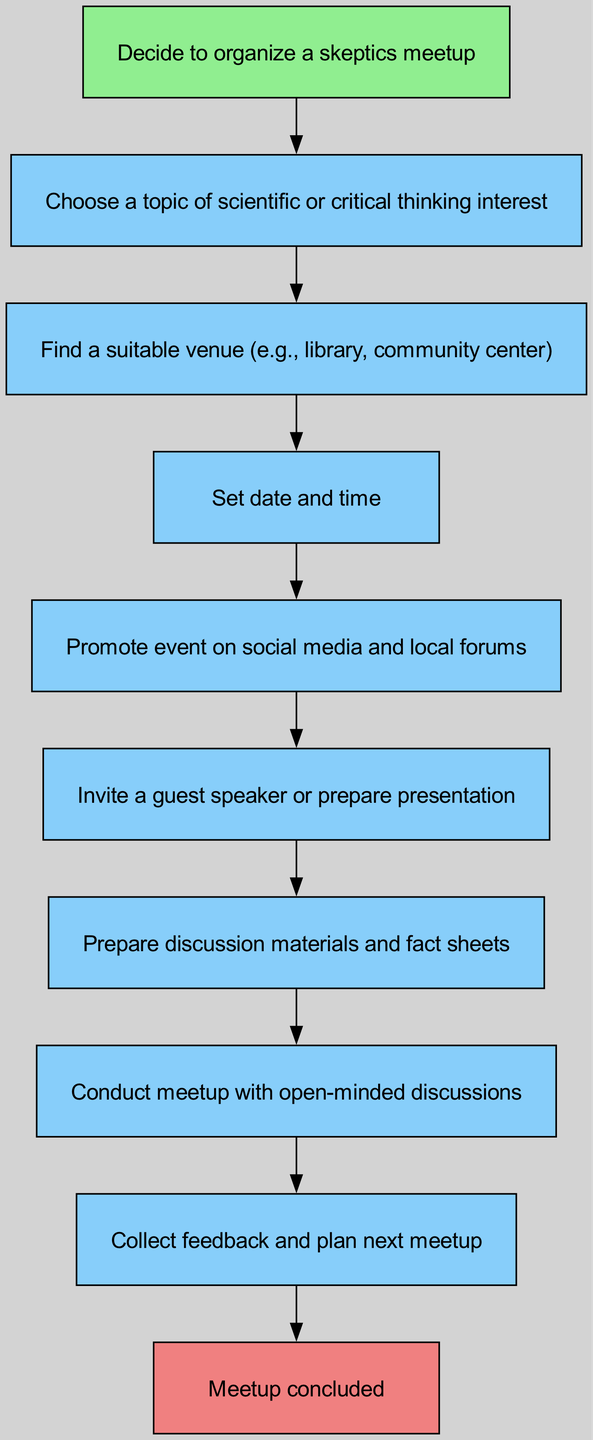What is the first step in organizing the meetup? The diagram indicates that the first node is "Decide to organize a skeptics meetup," which means this is the initial action taken.
Answer: Decide to organize a skeptics meetup How many total nodes are in the diagram? By counting the distinct steps in the diagram, we identify ten nodes that represent different actions or stages in the process.
Answer: Ten What action follows "Set date and time"? The flow chart shows the connection from "Set date and time" directly to "Promote event on social media and local forums," indicating the next step.
Answer: Promote event on social media and local forums What color represents the end of the process? The node labeled "Meetup concluded" is colored light coral, which is designated for end nodes in the diagram.
Answer: Light coral Which node is directly connected to "Prepare discussion materials and fact sheets"? The diagram reveals that "Conduct meetup with open-minded discussions" is the node immediately following "Prepare discussion materials and fact sheets," showing the progression in the flow.
Answer: Conduct meetup with open-minded discussions What step occurs after collecting feedback? The last step after "Collect feedback and plan next meetup" is "Meetup concluded," which signifies the closing of the current meetup cycle.
Answer: Meetup concluded How many connections are shown from the "Choose a topic of scientific or critical thinking interest" node? The flow chart illustrates one edge going from "Choose a topic of scientific or critical thinking interest" to "Find a suitable venue," denoting the direct link.
Answer: One What is the relationship between "Invite a guest speaker or prepare presentation" and "Prepare discussion materials and fact sheets"? "Invite a guest speaker or prepare presentation" leads directly to "Prepare discussion materials and fact sheets," indicating that these tasks are sequential in nature.
Answer: Direct connection Which node highlights preparation for discussions? The node labeled "Prepare discussion materials and fact sheets" is specifically focused on preparing materials necessary for the discussions at the meetup.
Answer: Prepare discussion materials and fact sheets What is the last action before the meetup is conducted? The action preceding the meetup is "Prepare discussion materials and fact sheets," which sets the foundation for the discussions during the event.
Answer: Prepare discussion materials and fact sheets 